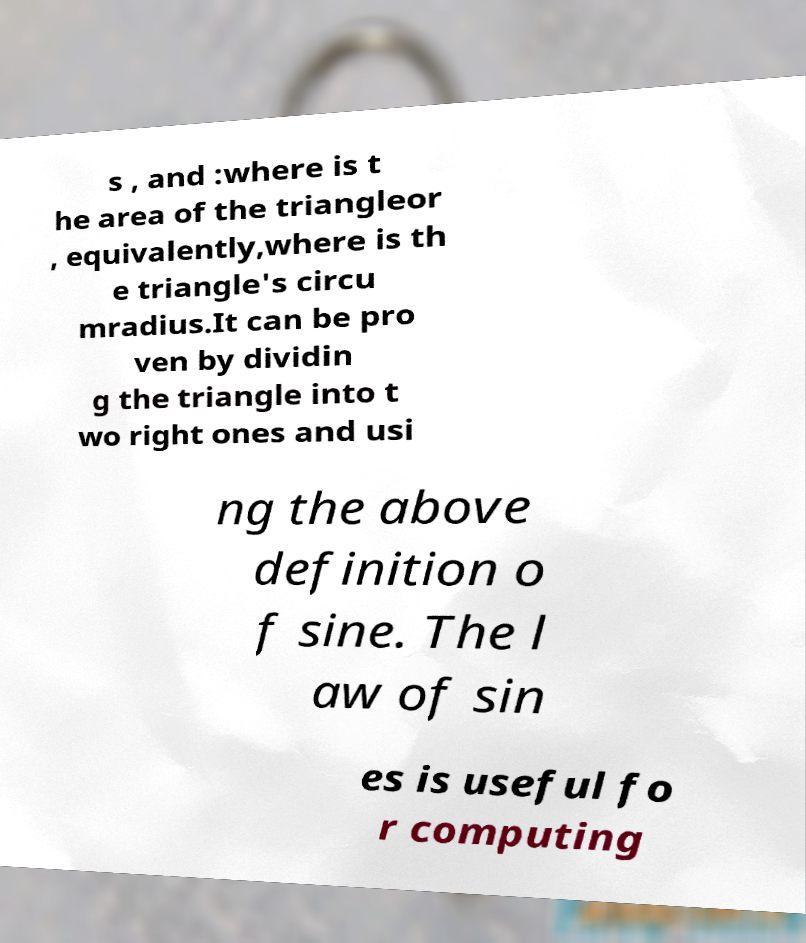Can you read and provide the text displayed in the image?This photo seems to have some interesting text. Can you extract and type it out for me? s , and :where is t he area of the triangleor , equivalently,where is th e triangle's circu mradius.It can be pro ven by dividin g the triangle into t wo right ones and usi ng the above definition o f sine. The l aw of sin es is useful fo r computing 